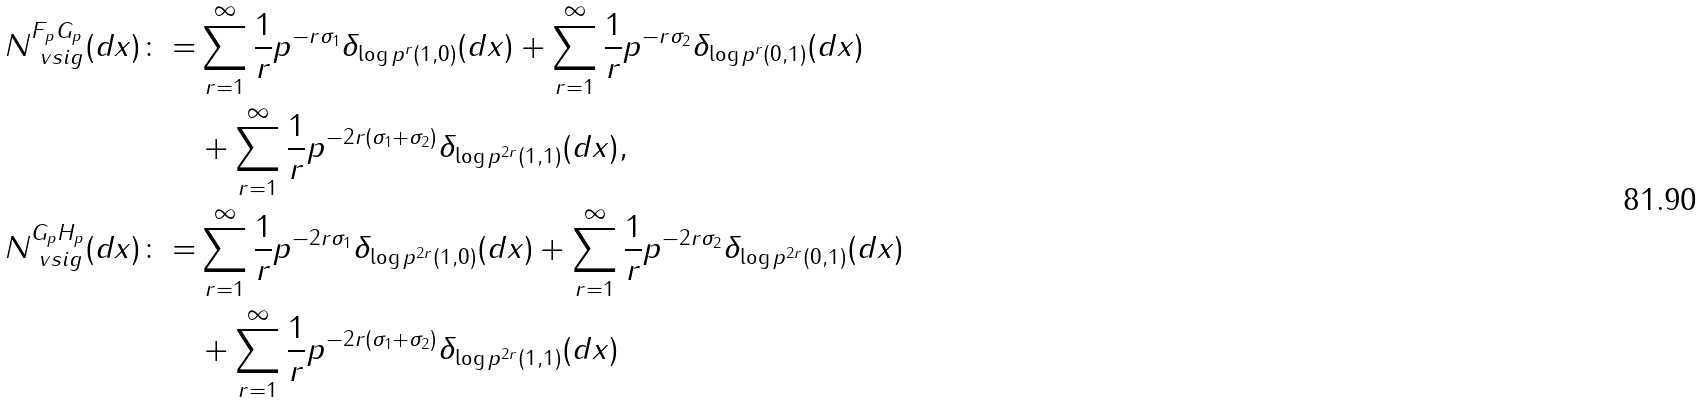<formula> <loc_0><loc_0><loc_500><loc_500>N ^ { F _ { p } G _ { p } } _ { \ v s i g } ( d x ) \colon = & \sum _ { r = 1 } ^ { \infty } \frac { 1 } { r } p ^ { - r \sigma _ { 1 } } \delta _ { \log p ^ { r } ( 1 , 0 ) } ( d x ) + \sum _ { r = 1 } ^ { \infty } \frac { 1 } { r } p ^ { - r \sigma _ { 2 } } \delta _ { \log p ^ { r } ( 0 , 1 ) } ( d x ) \\ & + \sum _ { r = 1 } ^ { \infty } \frac { 1 } { r } p ^ { - 2 r ( \sigma _ { 1 } + \sigma _ { 2 } ) } \delta _ { \log p ^ { 2 r } ( 1 , 1 ) } ( d x ) , \\ N ^ { G _ { p } H _ { p } } _ { \ v s i g } ( d x ) \colon = & \sum _ { r = 1 } ^ { \infty } \frac { 1 } { r } p ^ { - 2 r \sigma _ { 1 } } \delta _ { \log p ^ { 2 r } ( 1 , 0 ) } ( d x ) + \sum _ { r = 1 } ^ { \infty } \frac { 1 } { r } p ^ { - 2 r \sigma _ { 2 } } \delta _ { \log p ^ { 2 r } ( 0 , 1 ) } ( d x ) \\ & + \sum _ { r = 1 } ^ { \infty } \frac { 1 } { r } p ^ { - 2 r ( \sigma _ { 1 } + \sigma _ { 2 } ) } \delta _ { \log p ^ { 2 r } ( 1 , 1 ) } ( d x )</formula> 